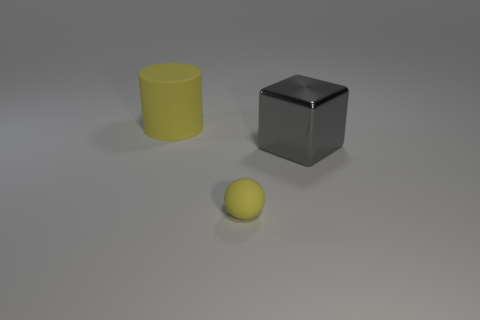Is the big matte object the same shape as the small yellow matte object?
Your answer should be very brief. No. Are there fewer tiny balls that are behind the large matte cylinder than rubber cylinders?
Offer a very short reply. Yes. There is a thing left of the yellow rubber thing in front of the big object in front of the rubber cylinder; what is its color?
Provide a short and direct response. Yellow. How many shiny things are either cubes or large green cylinders?
Your answer should be very brief. 1. Do the cylinder and the metal cube have the same size?
Offer a very short reply. Yes. Is the number of large yellow cylinders that are to the right of the big cylinder less than the number of matte objects that are behind the small thing?
Ensure brevity in your answer.  Yes. Is there any other thing that is the same size as the metallic object?
Give a very brief answer. Yes. How big is the shiny object?
Your response must be concise. Large. How many small things are either rubber things or yellow spheres?
Provide a short and direct response. 1. Do the yellow cylinder and the yellow matte thing in front of the large gray cube have the same size?
Your answer should be compact. No. 